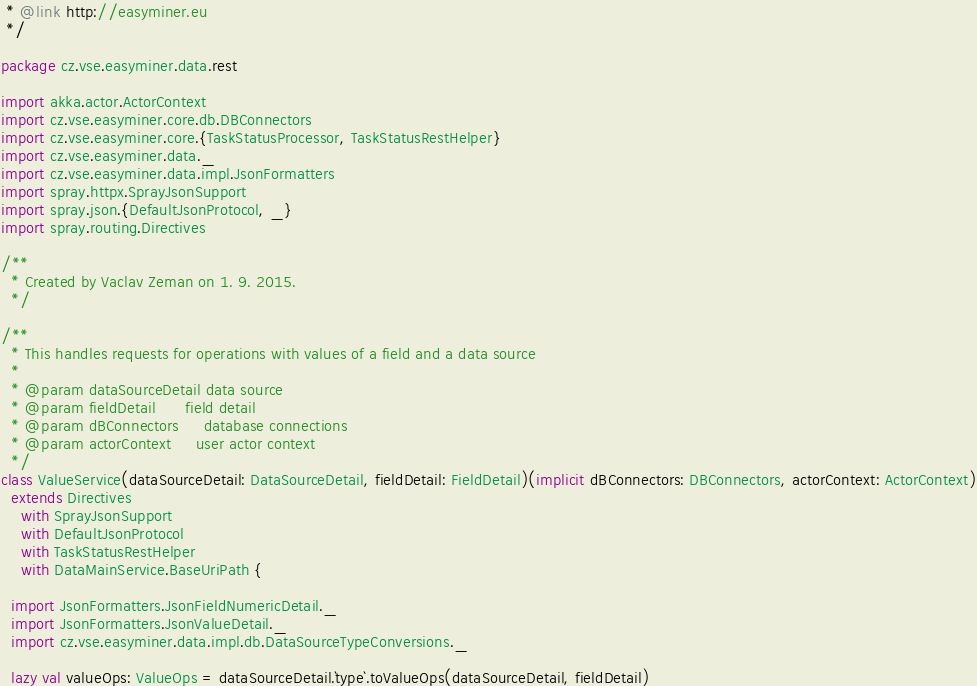Convert code to text. <code><loc_0><loc_0><loc_500><loc_500><_Scala_> * @link http://easyminer.eu
 */

package cz.vse.easyminer.data.rest

import akka.actor.ActorContext
import cz.vse.easyminer.core.db.DBConnectors
import cz.vse.easyminer.core.{TaskStatusProcessor, TaskStatusRestHelper}
import cz.vse.easyminer.data._
import cz.vse.easyminer.data.impl.JsonFormatters
import spray.httpx.SprayJsonSupport
import spray.json.{DefaultJsonProtocol, _}
import spray.routing.Directives

/**
  * Created by Vaclav Zeman on 1. 9. 2015.
  */

/**
  * This handles requests for operations with values of a field and a data source
  *
  * @param dataSourceDetail data source
  * @param fieldDetail      field detail
  * @param dBConnectors     database connections
  * @param actorContext     user actor context
  */
class ValueService(dataSourceDetail: DataSourceDetail, fieldDetail: FieldDetail)(implicit dBConnectors: DBConnectors, actorContext: ActorContext)
  extends Directives
    with SprayJsonSupport
    with DefaultJsonProtocol
    with TaskStatusRestHelper
    with DataMainService.BaseUriPath {

  import JsonFormatters.JsonFieldNumericDetail._
  import JsonFormatters.JsonValueDetail._
  import cz.vse.easyminer.data.impl.db.DataSourceTypeConversions._

  lazy val valueOps: ValueOps = dataSourceDetail.`type`.toValueOps(dataSourceDetail, fieldDetail)
</code> 